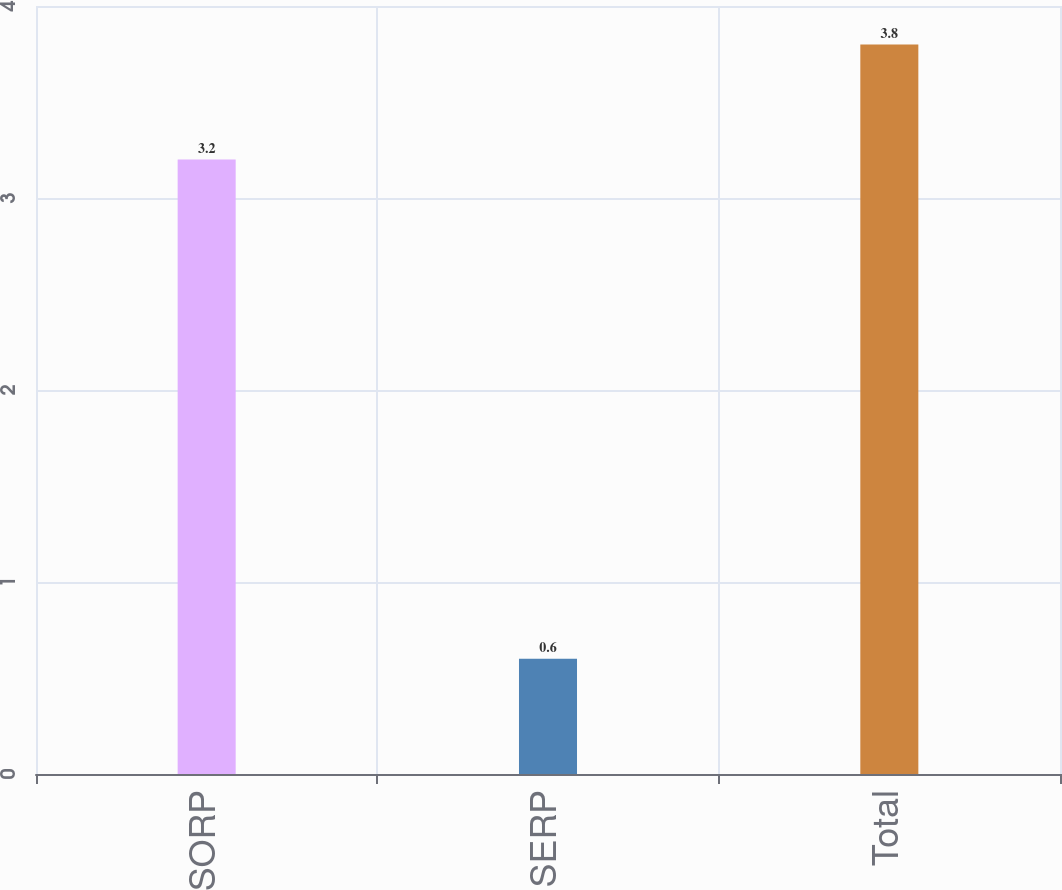Convert chart. <chart><loc_0><loc_0><loc_500><loc_500><bar_chart><fcel>SORP<fcel>SERP<fcel>Total<nl><fcel>3.2<fcel>0.6<fcel>3.8<nl></chart> 